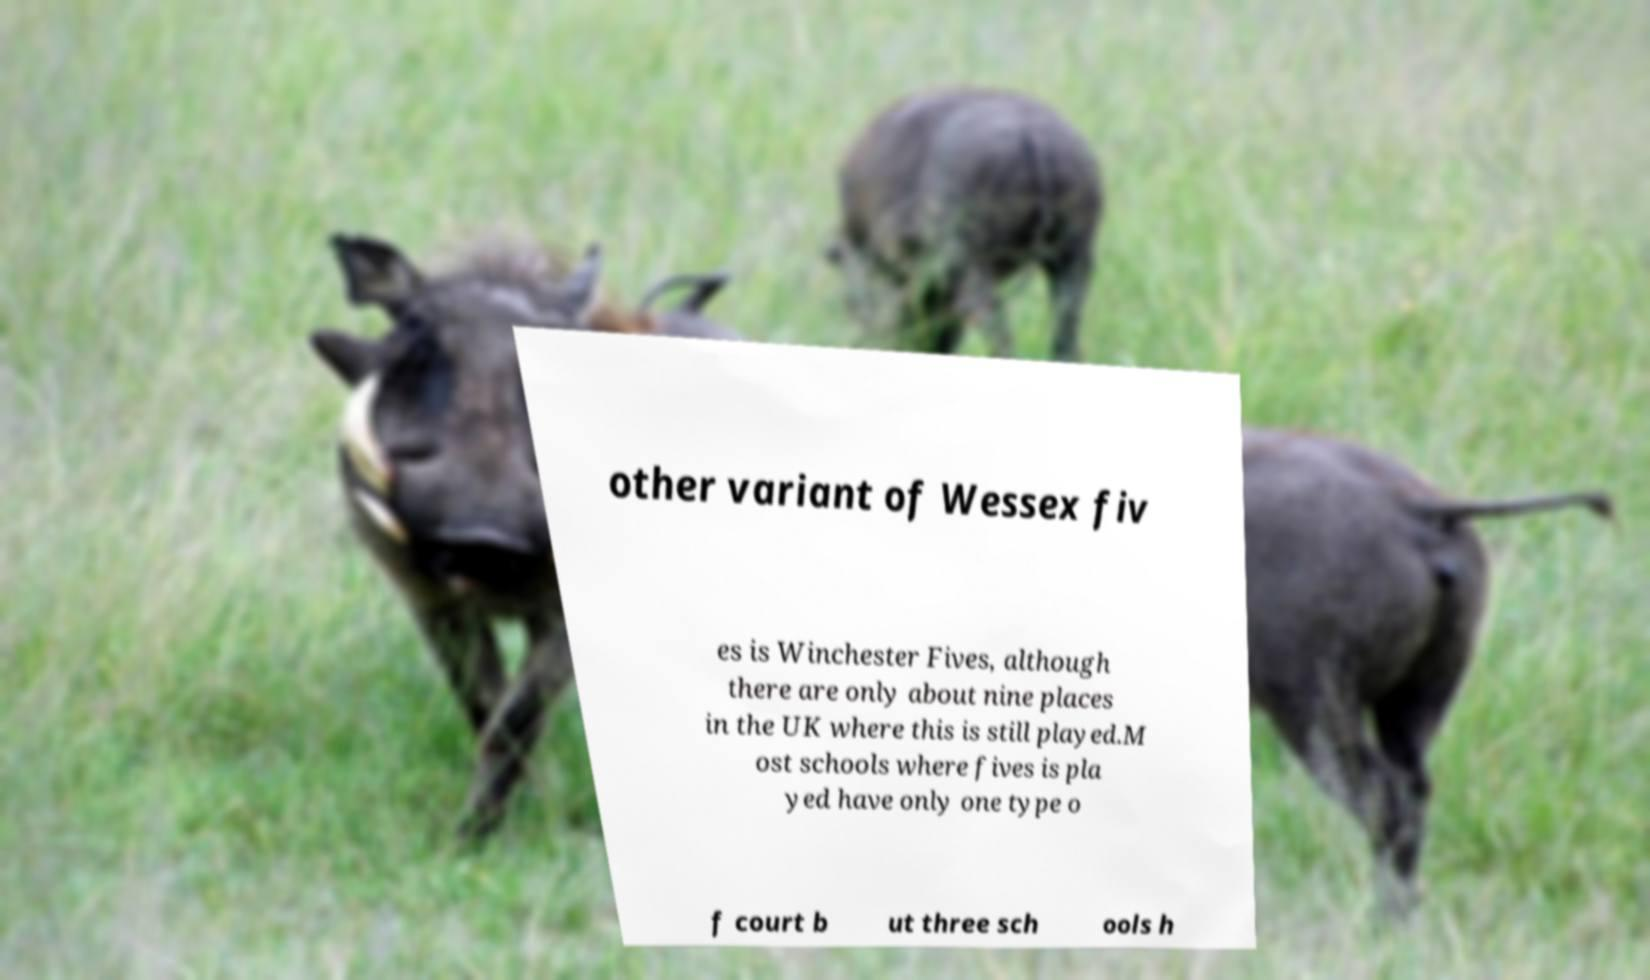For documentation purposes, I need the text within this image transcribed. Could you provide that? other variant of Wessex fiv es is Winchester Fives, although there are only about nine places in the UK where this is still played.M ost schools where fives is pla yed have only one type o f court b ut three sch ools h 